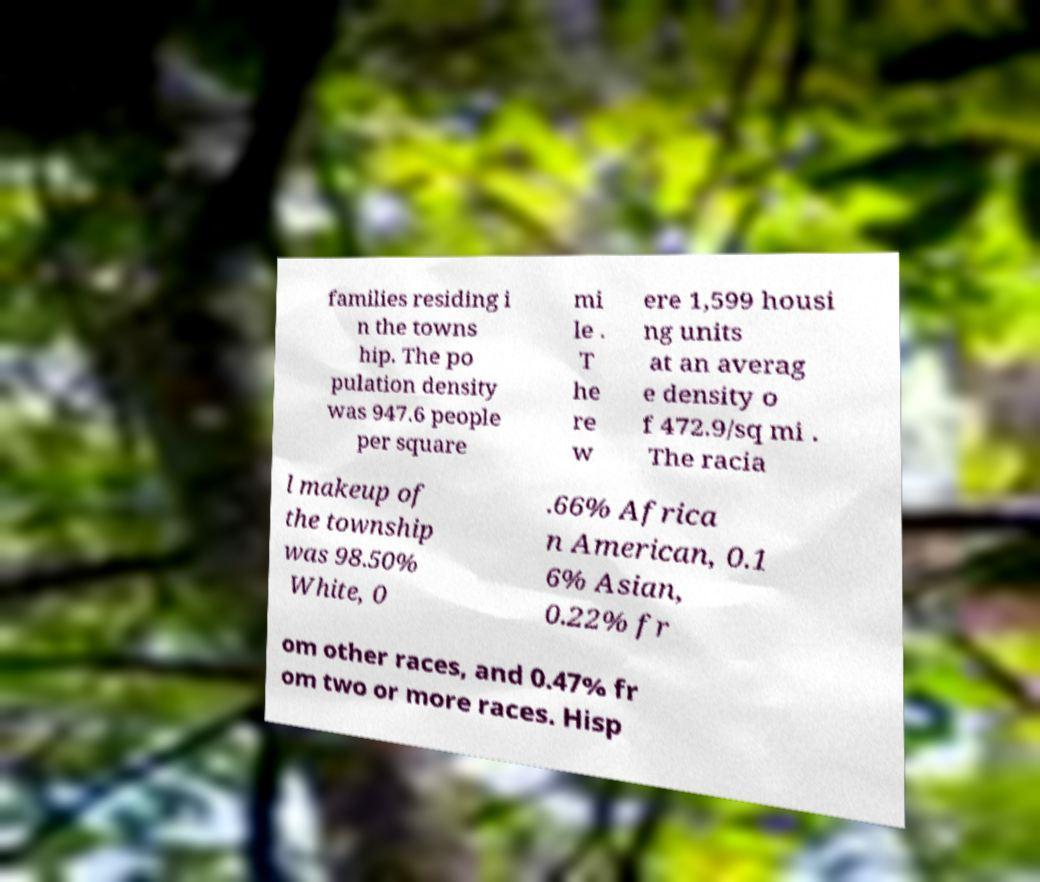Please identify and transcribe the text found in this image. families residing i n the towns hip. The po pulation density was 947.6 people per square mi le . T he re w ere 1,599 housi ng units at an averag e density o f 472.9/sq mi . The racia l makeup of the township was 98.50% White, 0 .66% Africa n American, 0.1 6% Asian, 0.22% fr om other races, and 0.47% fr om two or more races. Hisp 